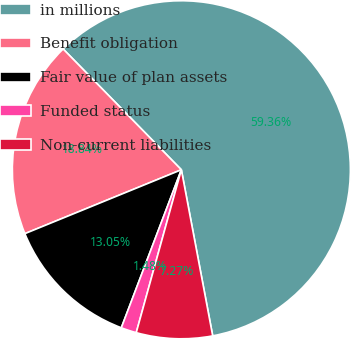<chart> <loc_0><loc_0><loc_500><loc_500><pie_chart><fcel>in millions<fcel>Benefit obligation<fcel>Fair value of plan assets<fcel>Funded status<fcel>Non-current liabilities<nl><fcel>59.36%<fcel>18.84%<fcel>13.05%<fcel>1.48%<fcel>7.27%<nl></chart> 